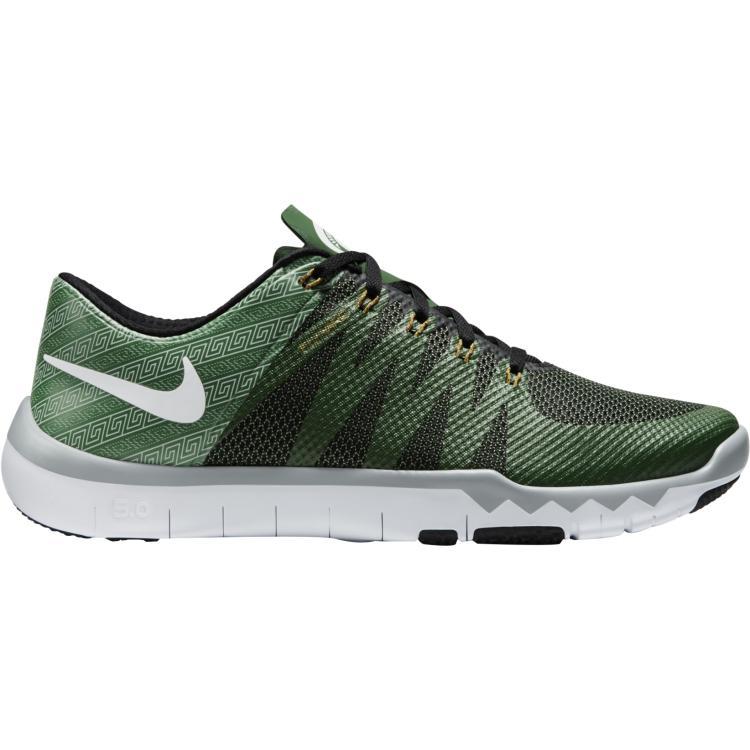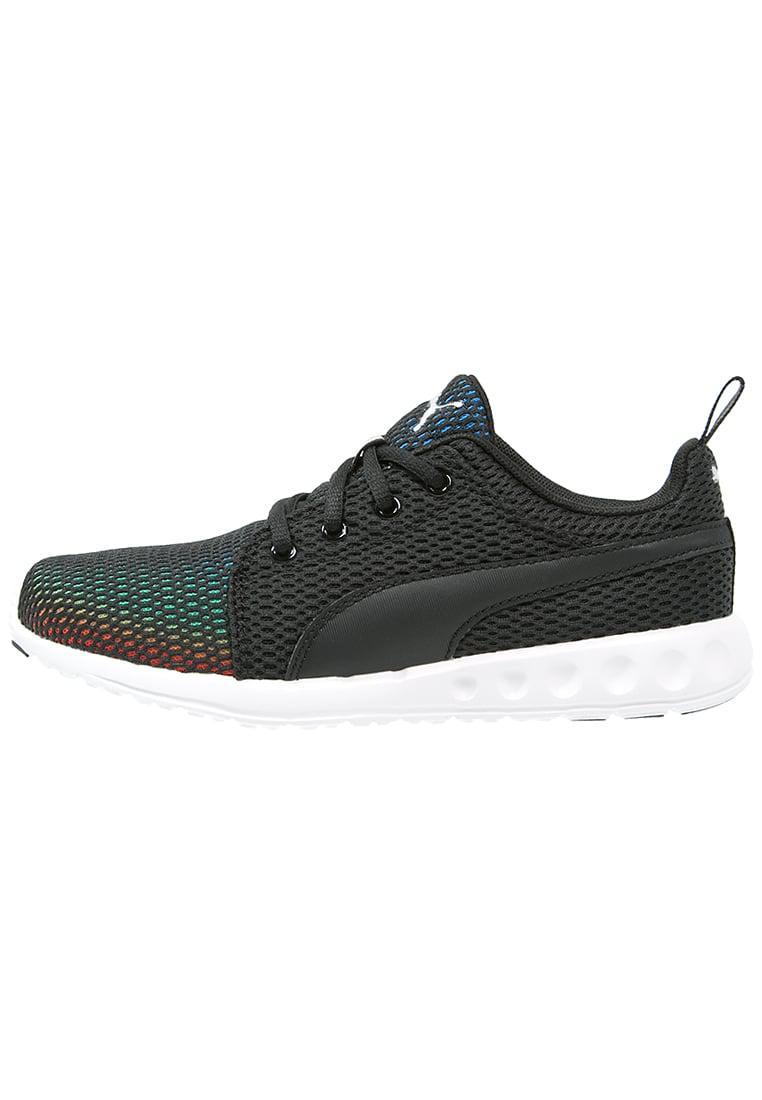The first image is the image on the left, the second image is the image on the right. Analyze the images presented: Is the assertion "all visible shoes have the toe side pointing towards the right" valid? Answer yes or no. No. The first image is the image on the left, the second image is the image on the right. Considering the images on both sides, is "All of the shoes are facing right." valid? Answer yes or no. No. 